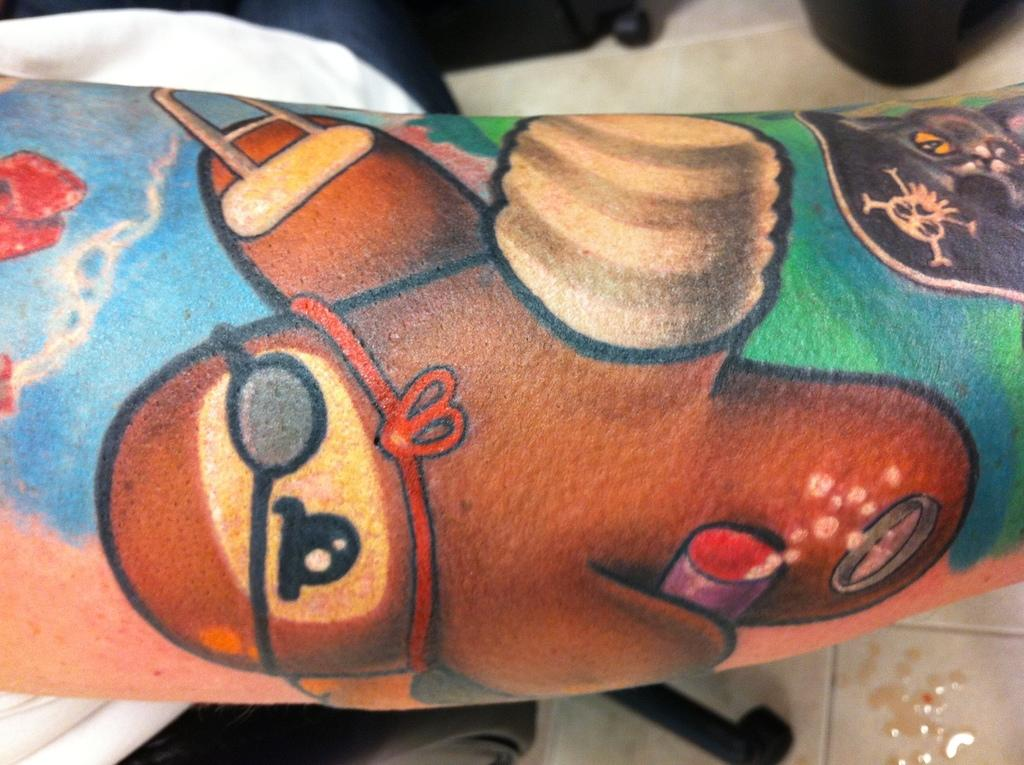What can be seen on the person's hand in the image? There is a tattoo on a person's hand in the image. What is located behind the hand in the image? There are wheels of a chair visible behind the hand. What else can be seen on the floor in the image? There are other objects on the floor in the image. What type of oil can be seen dripping from the person's face in the image? There is no person's face visible in the image, and therefore no oil dripping from it. How many birds are perched on the person's hand in the image? There are no birds present in the image; it only shows a tattoo on a person's hand. 